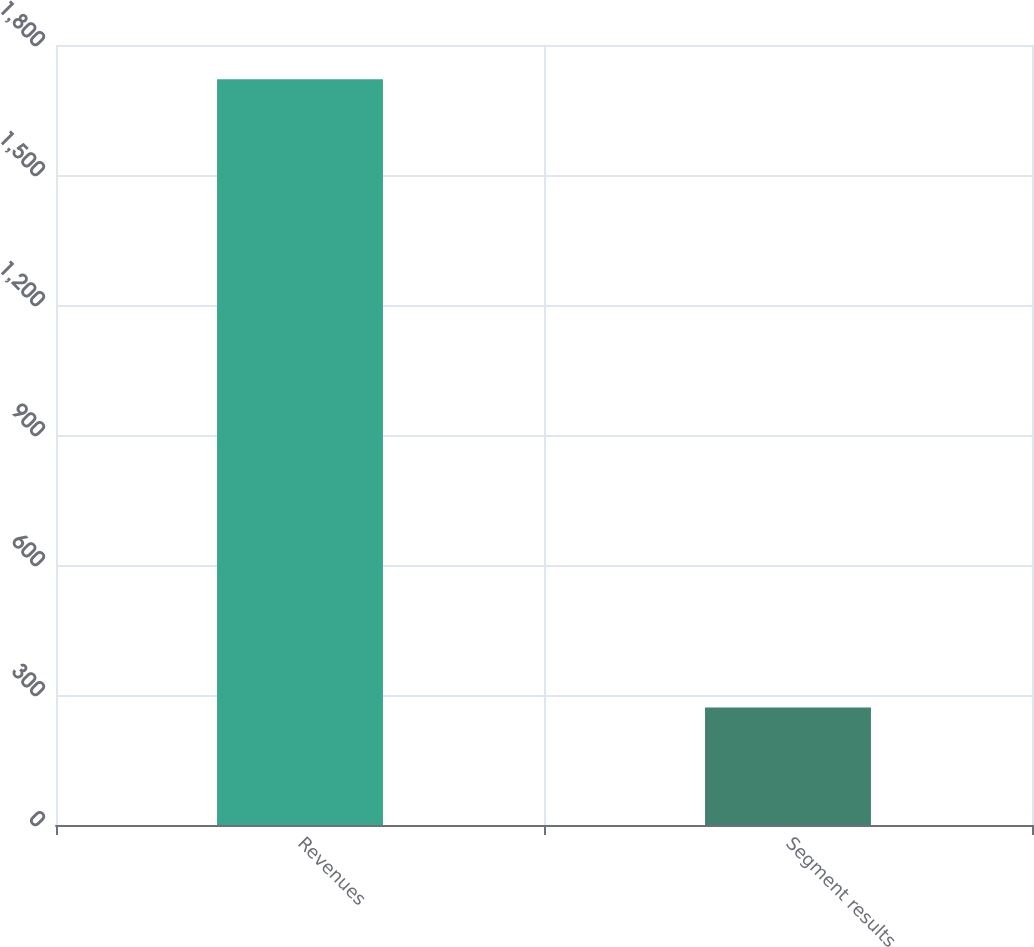Convert chart to OTSL. <chart><loc_0><loc_0><loc_500><loc_500><bar_chart><fcel>Revenues<fcel>Segment results<nl><fcel>1721<fcel>271<nl></chart> 